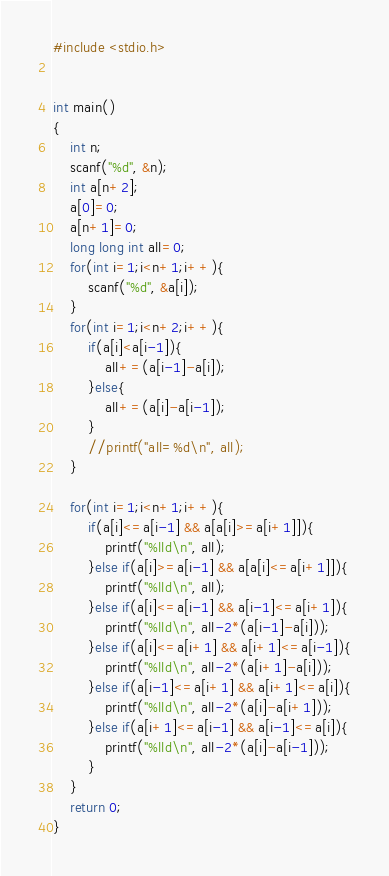Convert code to text. <code><loc_0><loc_0><loc_500><loc_500><_C_>#include <stdio.h>


int main()
{
    int n;
    scanf("%d", &n);
    int a[n+2];
    a[0]=0;
    a[n+1]=0;
    long long int all=0;
    for(int i=1;i<n+1;i++){
        scanf("%d", &a[i]);
    }
    for(int i=1;i<n+2;i++){
        if(a[i]<a[i-1]){
            all+=(a[i-1]-a[i]);
        }else{
            all+=(a[i]-a[i-1]);
        }
        //printf("all=%d\n", all);
    }

    for(int i=1;i<n+1;i++){
        if(a[i]<=a[i-1] && a[a[i]>=a[i+1]]){
            printf("%lld\n", all);
        }else if(a[i]>=a[i-1] && a[a[i]<=a[i+1]]){
            printf("%lld\n", all);
        }else if(a[i]<=a[i-1] && a[i-1]<=a[i+1]){
            printf("%lld\n", all-2*(a[i-1]-a[i]));
        }else if(a[i]<=a[i+1] && a[i+1]<=a[i-1]){
            printf("%lld\n", all-2*(a[i+1]-a[i]));
        }else if(a[i-1]<=a[i+1] && a[i+1]<=a[i]){
            printf("%lld\n", all-2*(a[i]-a[i+1]));
        }else if(a[i+1]<=a[i-1] && a[i-1]<=a[i]){
            printf("%lld\n", all-2*(a[i]-a[i-1]));
        }
    }
    return 0;
}
</code> 